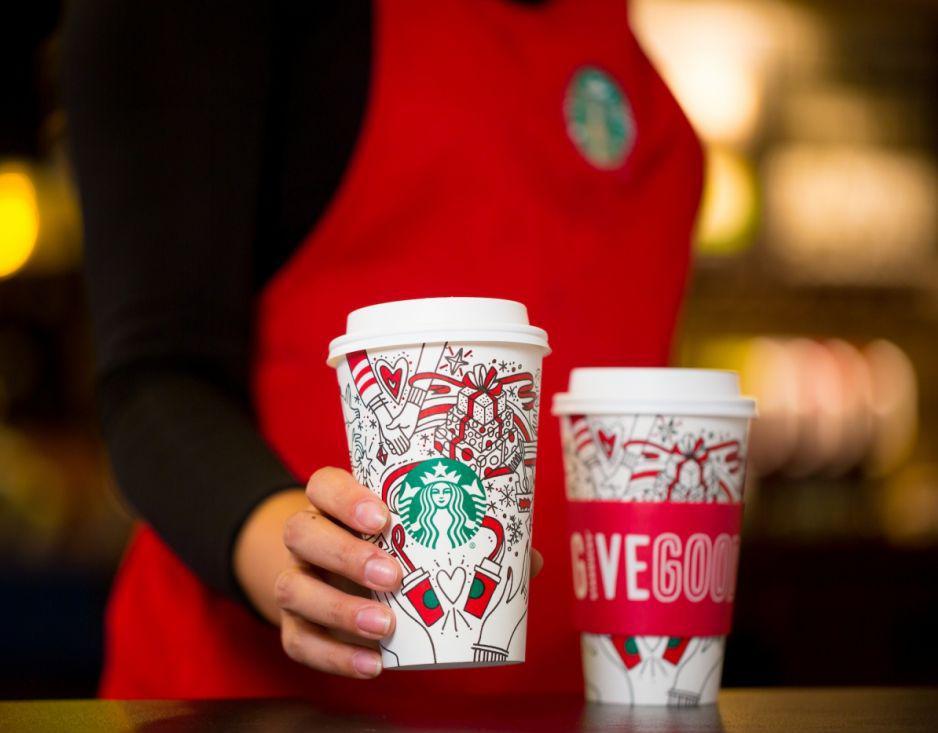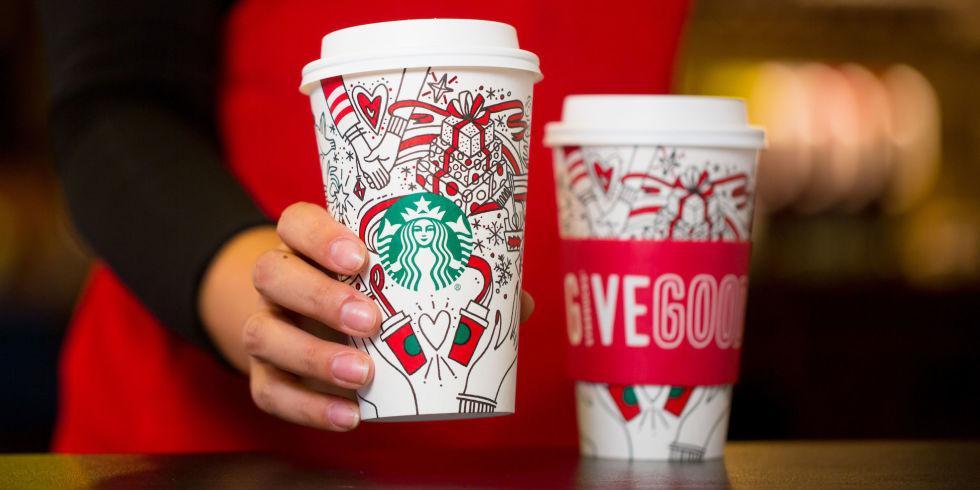The first image is the image on the left, the second image is the image on the right. Examine the images to the left and right. Is the description "In both images a person is holding a cup in their hand." accurate? Answer yes or no. Yes. 